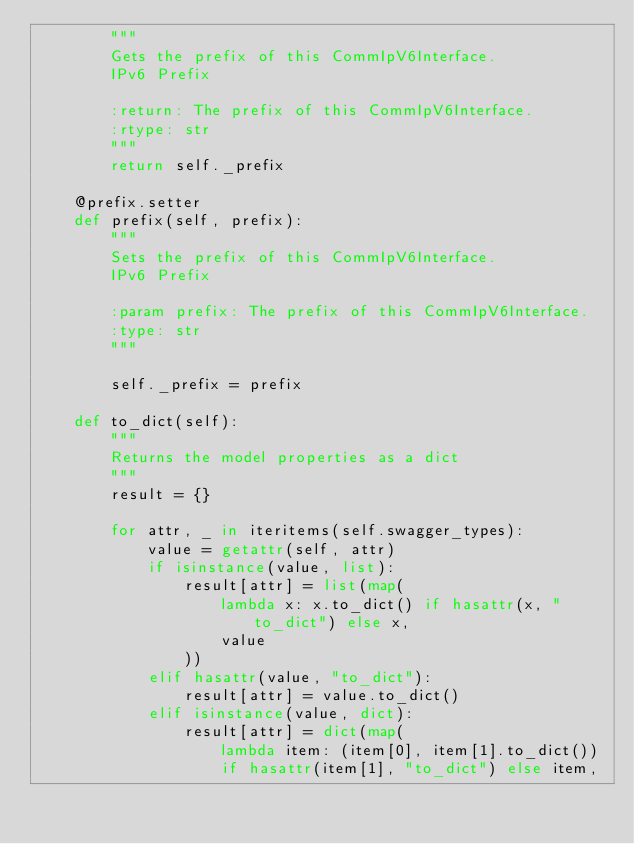Convert code to text. <code><loc_0><loc_0><loc_500><loc_500><_Python_>        """
        Gets the prefix of this CommIpV6Interface.
        IPv6 Prefix   

        :return: The prefix of this CommIpV6Interface.
        :rtype: str
        """
        return self._prefix

    @prefix.setter
    def prefix(self, prefix):
        """
        Sets the prefix of this CommIpV6Interface.
        IPv6 Prefix   

        :param prefix: The prefix of this CommIpV6Interface.
        :type: str
        """

        self._prefix = prefix

    def to_dict(self):
        """
        Returns the model properties as a dict
        """
        result = {}

        for attr, _ in iteritems(self.swagger_types):
            value = getattr(self, attr)
            if isinstance(value, list):
                result[attr] = list(map(
                    lambda x: x.to_dict() if hasattr(x, "to_dict") else x,
                    value
                ))
            elif hasattr(value, "to_dict"):
                result[attr] = value.to_dict()
            elif isinstance(value, dict):
                result[attr] = dict(map(
                    lambda item: (item[0], item[1].to_dict())
                    if hasattr(item[1], "to_dict") else item,</code> 